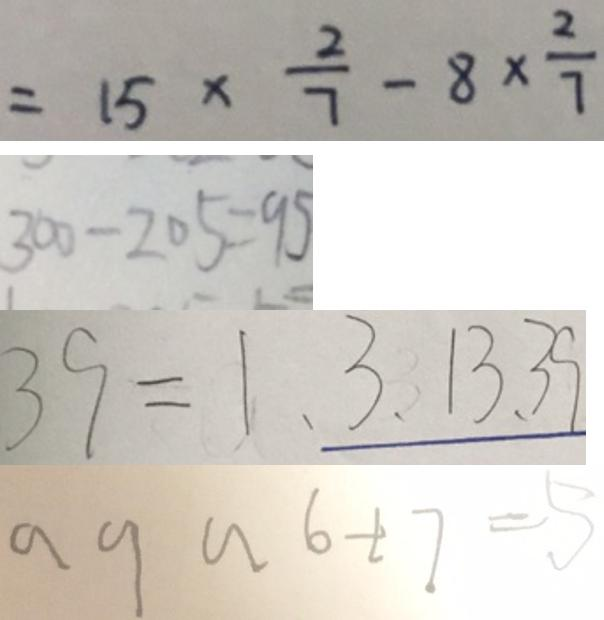<formula> <loc_0><loc_0><loc_500><loc_500>= 1 5 \times \frac { 2 } { 7 } - 8 \times \frac { 2 } { 7 } 
 3 0 0 - 2 0 5 = 9 5 
 3 9 = 1 、 3 、 1 3 、 3 9 
 a 9 a 6 + 7 = 5</formula> 